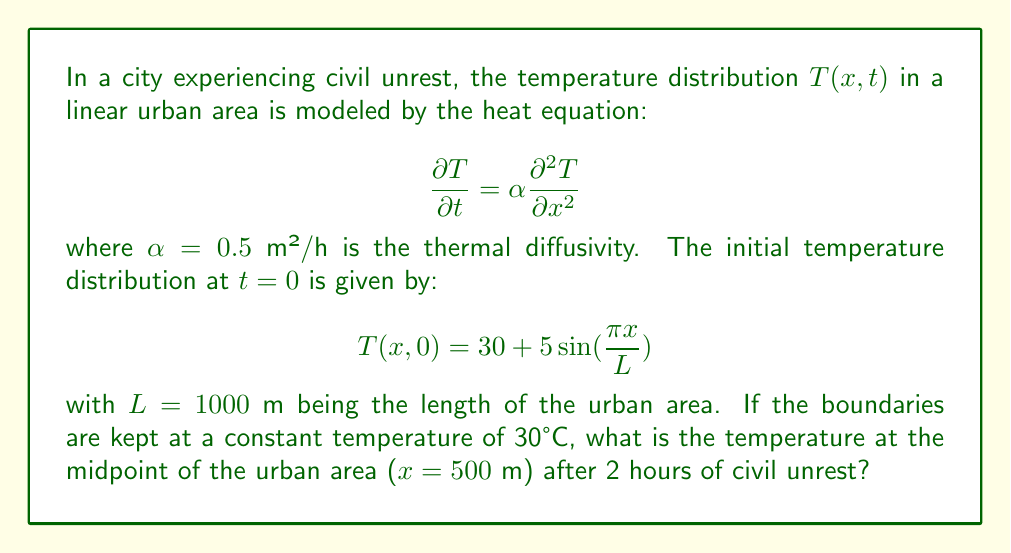Can you solve this math problem? To solve this problem, we need to use the separation of variables method for the heat equation with given boundary conditions:

1. The general solution for the heat equation with these boundary conditions is:

   $$T(x,t) = 30 + \sum_{n=1}^{\infty} B_n \sin(\frac{n\pi x}{L})e^{-\alpha(\frac{n\pi}{L})^2t}$$

2. We need to find $B_n$ using the initial condition:

   $$30 + 5\sin(\frac{\pi x}{L}) = 30 + \sum_{n=1}^{\infty} B_n \sin(\frac{n\pi x}{L})$$

3. Comparing the terms, we can see that $B_1 = 5$ and $B_n = 0$ for $n > 1$.

4. Therefore, our solution simplifies to:

   $$T(x,t) = 30 + 5\sin(\frac{\pi x}{L})e^{-\alpha(\frac{\pi}{L})^2t}$$

5. Now, we can calculate the temperature at $x = 500$ m and $t = 2$ hours:

   $$T(500, 2) = 30 + 5\sin(\frac{\pi \cdot 500}{1000})e^{-0.5(\frac{\pi}{1000})^2 \cdot 2}$$

6. Simplify:
   
   $$T(500, 2) = 30 + 5\sin(\frac{\pi}{2})e^{-\frac{\pi^2}{10^6}}$$

7. Calculate:
   
   $$T(500, 2) = 30 + 5 \cdot 1 \cdot 0.9901 = 34.9505°C$$
Answer: 34.95°C 